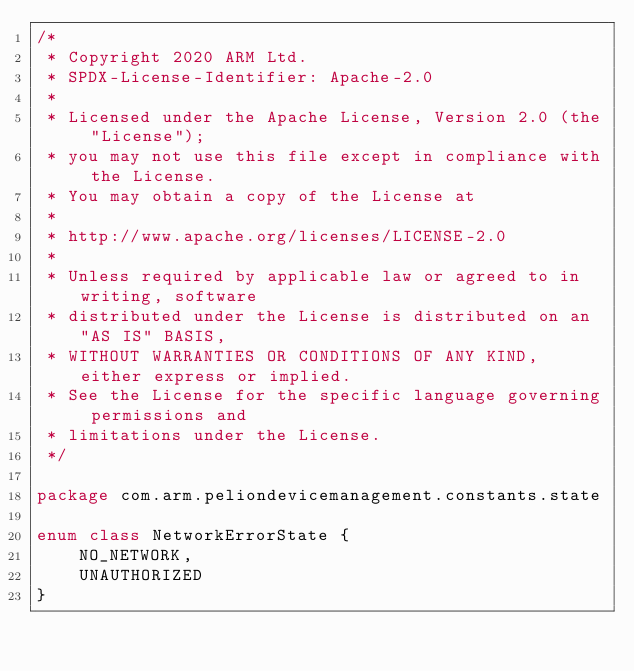<code> <loc_0><loc_0><loc_500><loc_500><_Kotlin_>/*
 * Copyright 2020 ARM Ltd.
 * SPDX-License-Identifier: Apache-2.0
 *
 * Licensed under the Apache License, Version 2.0 (the "License");
 * you may not use this file except in compliance with the License.
 * You may obtain a copy of the License at
 *
 * http://www.apache.org/licenses/LICENSE-2.0
 *
 * Unless required by applicable law or agreed to in writing, software
 * distributed under the License is distributed on an "AS IS" BASIS,
 * WITHOUT WARRANTIES OR CONDITIONS OF ANY KIND, either express or implied.
 * See the License for the specific language governing permissions and
 * limitations under the License.
 */

package com.arm.peliondevicemanagement.constants.state

enum class NetworkErrorState {
    NO_NETWORK,
    UNAUTHORIZED
}</code> 